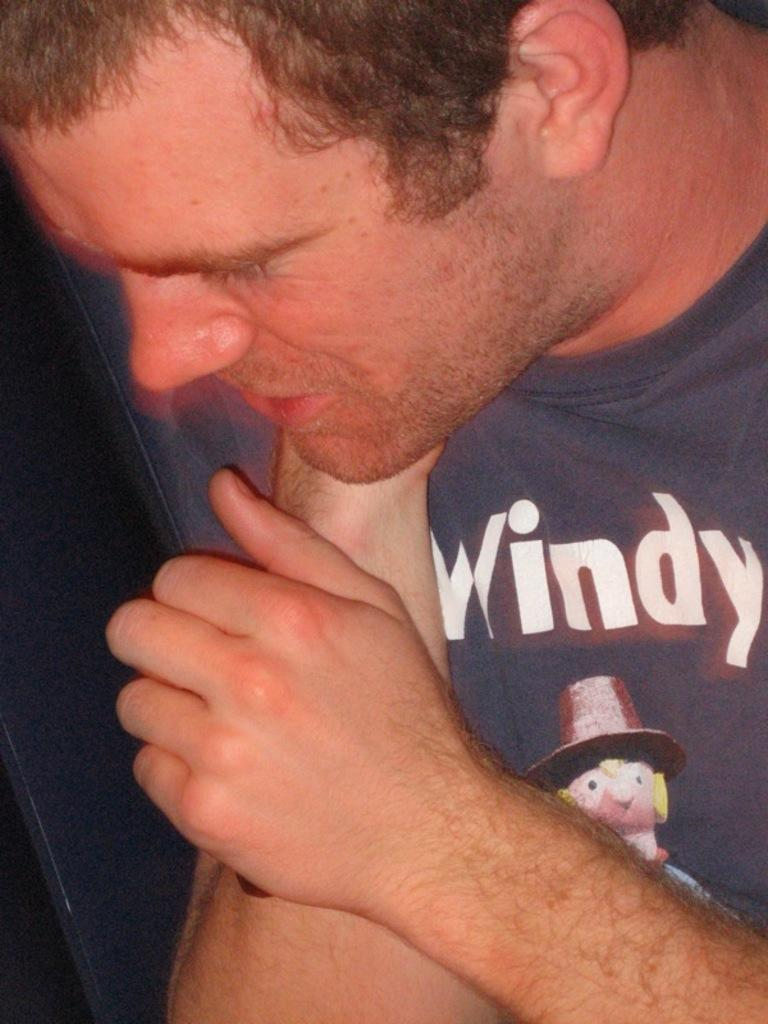Who or what is the main subject of the image? There is a person in the image. Can you describe the background of the image? The background of the image is dark. What type of society is depicted in the image? There is no society depicted in the image; it only features a person and a dark background. 